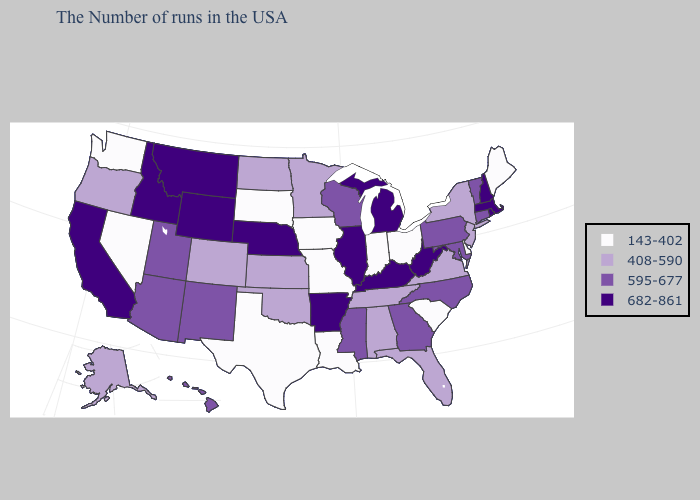How many symbols are there in the legend?
Write a very short answer. 4. Does Minnesota have a lower value than Maryland?
Quick response, please. Yes. What is the value of Kentucky?
Be succinct. 682-861. Does Vermont have the highest value in the USA?
Quick response, please. No. Which states have the lowest value in the West?
Concise answer only. Nevada, Washington. What is the value of North Carolina?
Keep it brief. 595-677. Does Pennsylvania have the highest value in the Northeast?
Concise answer only. No. Name the states that have a value in the range 408-590?
Keep it brief. New York, New Jersey, Virginia, Florida, Alabama, Tennessee, Minnesota, Kansas, Oklahoma, North Dakota, Colorado, Oregon, Alaska. What is the value of Iowa?
Quick response, please. 143-402. Which states have the lowest value in the USA?
Give a very brief answer. Maine, Delaware, South Carolina, Ohio, Indiana, Louisiana, Missouri, Iowa, Texas, South Dakota, Nevada, Washington. Which states have the lowest value in the Northeast?
Write a very short answer. Maine. What is the highest value in states that border Connecticut?
Short answer required. 682-861. Does Florida have the highest value in the USA?
Answer briefly. No. Which states have the lowest value in the South?
Give a very brief answer. Delaware, South Carolina, Louisiana, Texas. 